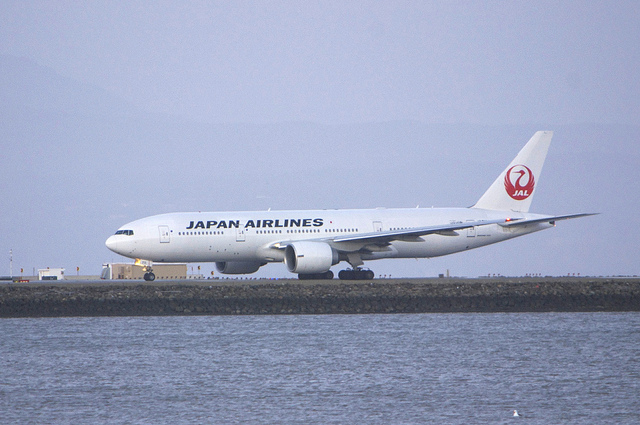Read all the text in this image. JAPAN AIRLINES SAL 